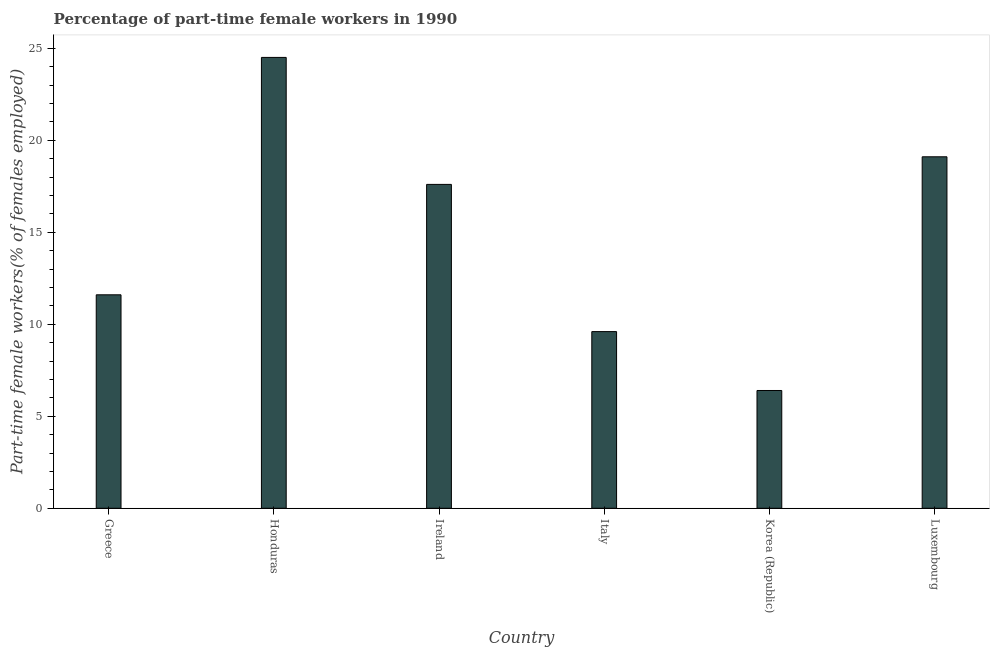Does the graph contain any zero values?
Your answer should be very brief. No. Does the graph contain grids?
Make the answer very short. No. What is the title of the graph?
Give a very brief answer. Percentage of part-time female workers in 1990. What is the label or title of the Y-axis?
Make the answer very short. Part-time female workers(% of females employed). What is the percentage of part-time female workers in Ireland?
Give a very brief answer. 17.6. Across all countries, what is the minimum percentage of part-time female workers?
Offer a very short reply. 6.4. In which country was the percentage of part-time female workers maximum?
Give a very brief answer. Honduras. In which country was the percentage of part-time female workers minimum?
Give a very brief answer. Korea (Republic). What is the sum of the percentage of part-time female workers?
Offer a terse response. 88.8. What is the difference between the percentage of part-time female workers in Greece and Luxembourg?
Your answer should be very brief. -7.5. What is the average percentage of part-time female workers per country?
Offer a very short reply. 14.8. What is the median percentage of part-time female workers?
Ensure brevity in your answer.  14.6. In how many countries, is the percentage of part-time female workers greater than 18 %?
Provide a short and direct response. 2. What is the ratio of the percentage of part-time female workers in Ireland to that in Luxembourg?
Your answer should be very brief. 0.92. What is the difference between the highest and the lowest percentage of part-time female workers?
Your answer should be very brief. 18.1. Are all the bars in the graph horizontal?
Offer a very short reply. No. What is the difference between two consecutive major ticks on the Y-axis?
Make the answer very short. 5. Are the values on the major ticks of Y-axis written in scientific E-notation?
Provide a succinct answer. No. What is the Part-time female workers(% of females employed) of Greece?
Ensure brevity in your answer.  11.6. What is the Part-time female workers(% of females employed) of Ireland?
Your answer should be compact. 17.6. What is the Part-time female workers(% of females employed) in Italy?
Offer a very short reply. 9.6. What is the Part-time female workers(% of females employed) in Korea (Republic)?
Your response must be concise. 6.4. What is the Part-time female workers(% of females employed) of Luxembourg?
Offer a very short reply. 19.1. What is the difference between the Part-time female workers(% of females employed) in Greece and Honduras?
Offer a terse response. -12.9. What is the difference between the Part-time female workers(% of females employed) in Greece and Ireland?
Give a very brief answer. -6. What is the difference between the Part-time female workers(% of females employed) in Greece and Italy?
Your response must be concise. 2. What is the difference between the Part-time female workers(% of females employed) in Greece and Korea (Republic)?
Make the answer very short. 5.2. What is the difference between the Part-time female workers(% of females employed) in Honduras and Ireland?
Your answer should be very brief. 6.9. What is the difference between the Part-time female workers(% of females employed) in Honduras and Italy?
Ensure brevity in your answer.  14.9. What is the difference between the Part-time female workers(% of females employed) in Honduras and Korea (Republic)?
Your answer should be compact. 18.1. What is the difference between the Part-time female workers(% of females employed) in Honduras and Luxembourg?
Offer a terse response. 5.4. What is the difference between the Part-time female workers(% of females employed) in Ireland and Italy?
Your answer should be very brief. 8. What is the difference between the Part-time female workers(% of females employed) in Italy and Luxembourg?
Offer a terse response. -9.5. What is the ratio of the Part-time female workers(% of females employed) in Greece to that in Honduras?
Ensure brevity in your answer.  0.47. What is the ratio of the Part-time female workers(% of females employed) in Greece to that in Ireland?
Give a very brief answer. 0.66. What is the ratio of the Part-time female workers(% of females employed) in Greece to that in Italy?
Provide a succinct answer. 1.21. What is the ratio of the Part-time female workers(% of females employed) in Greece to that in Korea (Republic)?
Your answer should be very brief. 1.81. What is the ratio of the Part-time female workers(% of females employed) in Greece to that in Luxembourg?
Your answer should be compact. 0.61. What is the ratio of the Part-time female workers(% of females employed) in Honduras to that in Ireland?
Your answer should be compact. 1.39. What is the ratio of the Part-time female workers(% of females employed) in Honduras to that in Italy?
Offer a very short reply. 2.55. What is the ratio of the Part-time female workers(% of females employed) in Honduras to that in Korea (Republic)?
Give a very brief answer. 3.83. What is the ratio of the Part-time female workers(% of females employed) in Honduras to that in Luxembourg?
Your answer should be compact. 1.28. What is the ratio of the Part-time female workers(% of females employed) in Ireland to that in Italy?
Your answer should be very brief. 1.83. What is the ratio of the Part-time female workers(% of females employed) in Ireland to that in Korea (Republic)?
Offer a terse response. 2.75. What is the ratio of the Part-time female workers(% of females employed) in Ireland to that in Luxembourg?
Your answer should be very brief. 0.92. What is the ratio of the Part-time female workers(% of females employed) in Italy to that in Korea (Republic)?
Your response must be concise. 1.5. What is the ratio of the Part-time female workers(% of females employed) in Italy to that in Luxembourg?
Keep it short and to the point. 0.5. What is the ratio of the Part-time female workers(% of females employed) in Korea (Republic) to that in Luxembourg?
Offer a very short reply. 0.34. 